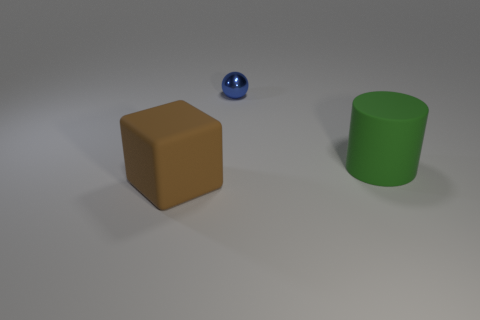Add 1 large brown things. How many objects exist? 4 Subtract all large matte things. Subtract all brown cubes. How many objects are left? 0 Add 1 green objects. How many green objects are left? 2 Add 1 green things. How many green things exist? 2 Subtract 0 red cubes. How many objects are left? 3 Subtract all cylinders. How many objects are left? 2 